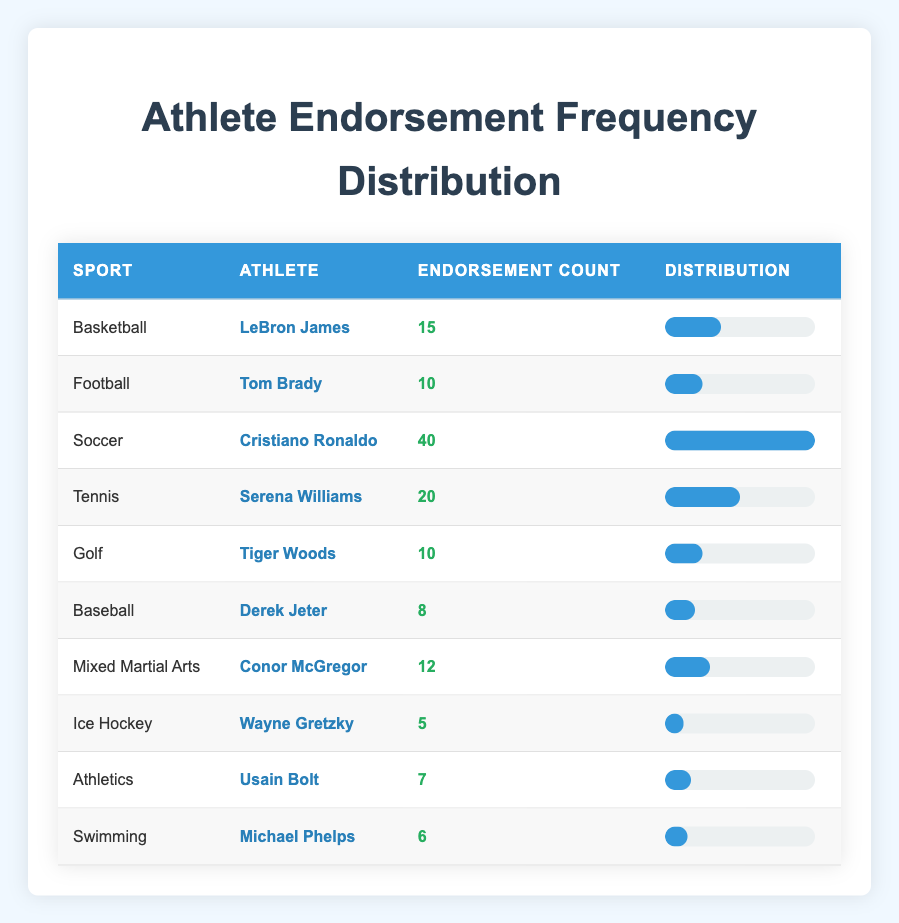What is the highest number of endorsements recorded in the table? The highest number of endorsements belongs to Cristiano Ronaldo with 40 endorsements. This can be confirmed by looking at the "Endorsement Count" column and finding the maximum value.
Answer: 40 Which sport has the second most endorsements? Tennis has the second most endorsements with a total of 20 endorsements from Serena Williams, following Soccer, which has the highest with 40 endorsements. Thus, comparing the endorsement counts, Tennis ranks second.
Answer: Tennis Is there any athlete in the table with fewer than 10 endorsements? Yes, there are athletes with fewer than 10 endorsements. Specifically, Derek Jeter has 8 endorsements, Wayne Gretzky has 5, Usain Bolt has 7, and Michael Phelps has 6. Therefore, it is true that some athletes have fewer than 10 endorsements.
Answer: Yes What is the total number of endorsements for Football and Golf combined? To find the total endorsements for Football and Golf, we add Tom Brady's 10 endorsements and Tiger Woods' 10 endorsements together: 10 + 10 = 20 endorsements in total. This requires summing the individual counts from the respective sports.
Answer: 20 Which athlete has the least number of endorsements? The athlete with the least number of endorsements is Wayne Gretzky, who has only 5 endorsements. This can be determined by reviewing the table and identifying the minimum value under the "Endorsement Count" column.
Answer: Wayne Gretzky What is the average number of endorsements across all the athletes listed? To find the average, we first sum all endorsements: 15 + 10 + 40 + 20 + 10 + 8 + 12 + 5 + 7 + 6 = 133. There are 10 athletes in total, so we divide 133 by 10, resulting in an average of 13.3 endorsements per athlete. This involves applying the formula for the average and ensuring all endorsements are included.
Answer: 13.3 Which sport has the highest endorsement count, and how does its count compare to Basketball? Soccer has the highest endorsement count at 40 endorsements, while Basketball has 15 endorsements. The difference between them is 40 - 15 = 25 endorsements, indicating Soccer leads by 25 endorsements over Basketball. This comparison involves identifying and contrasting the values in the respective rows.
Answer: Soccer; 25 How many athletes have 10 endorsements or more? There are six athletes with 10 endorsements or more: LeBron James (15), Tom Brady (10), Cristiano Ronaldo (40), Serena Williams (20), Conor McGregor (12), and Tiger Woods (10). Adding these up confirms that six athletes meet the criterion. This requires inspecting each entry and counting those that fulfill the requirement.
Answer: 6 